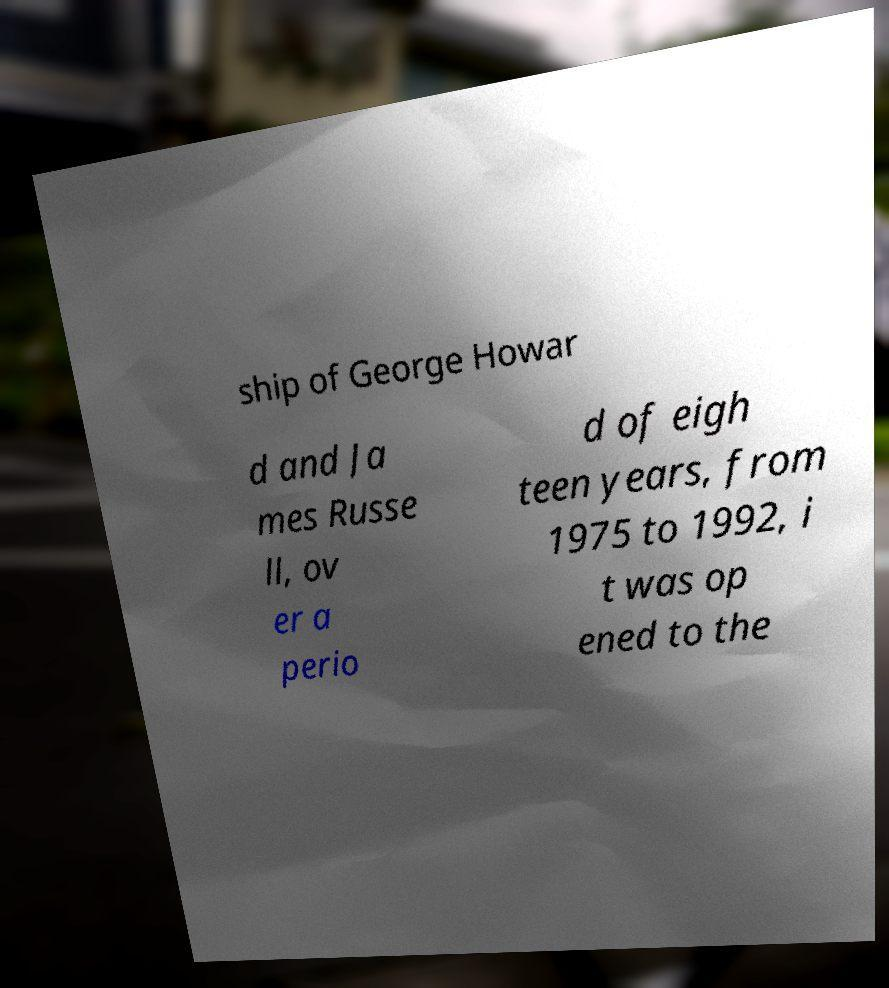For documentation purposes, I need the text within this image transcribed. Could you provide that? ship of George Howar d and Ja mes Russe ll, ov er a perio d of eigh teen years, from 1975 to 1992, i t was op ened to the 